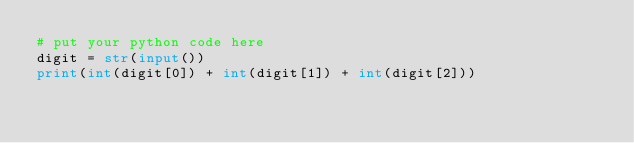Convert code to text. <code><loc_0><loc_0><loc_500><loc_500><_Python_># put your python code here
digit = str(input())
print(int(digit[0]) + int(digit[1]) + int(digit[2]))
</code> 